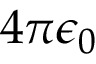<formula> <loc_0><loc_0><loc_500><loc_500>4 \pi \epsilon _ { 0 }</formula> 